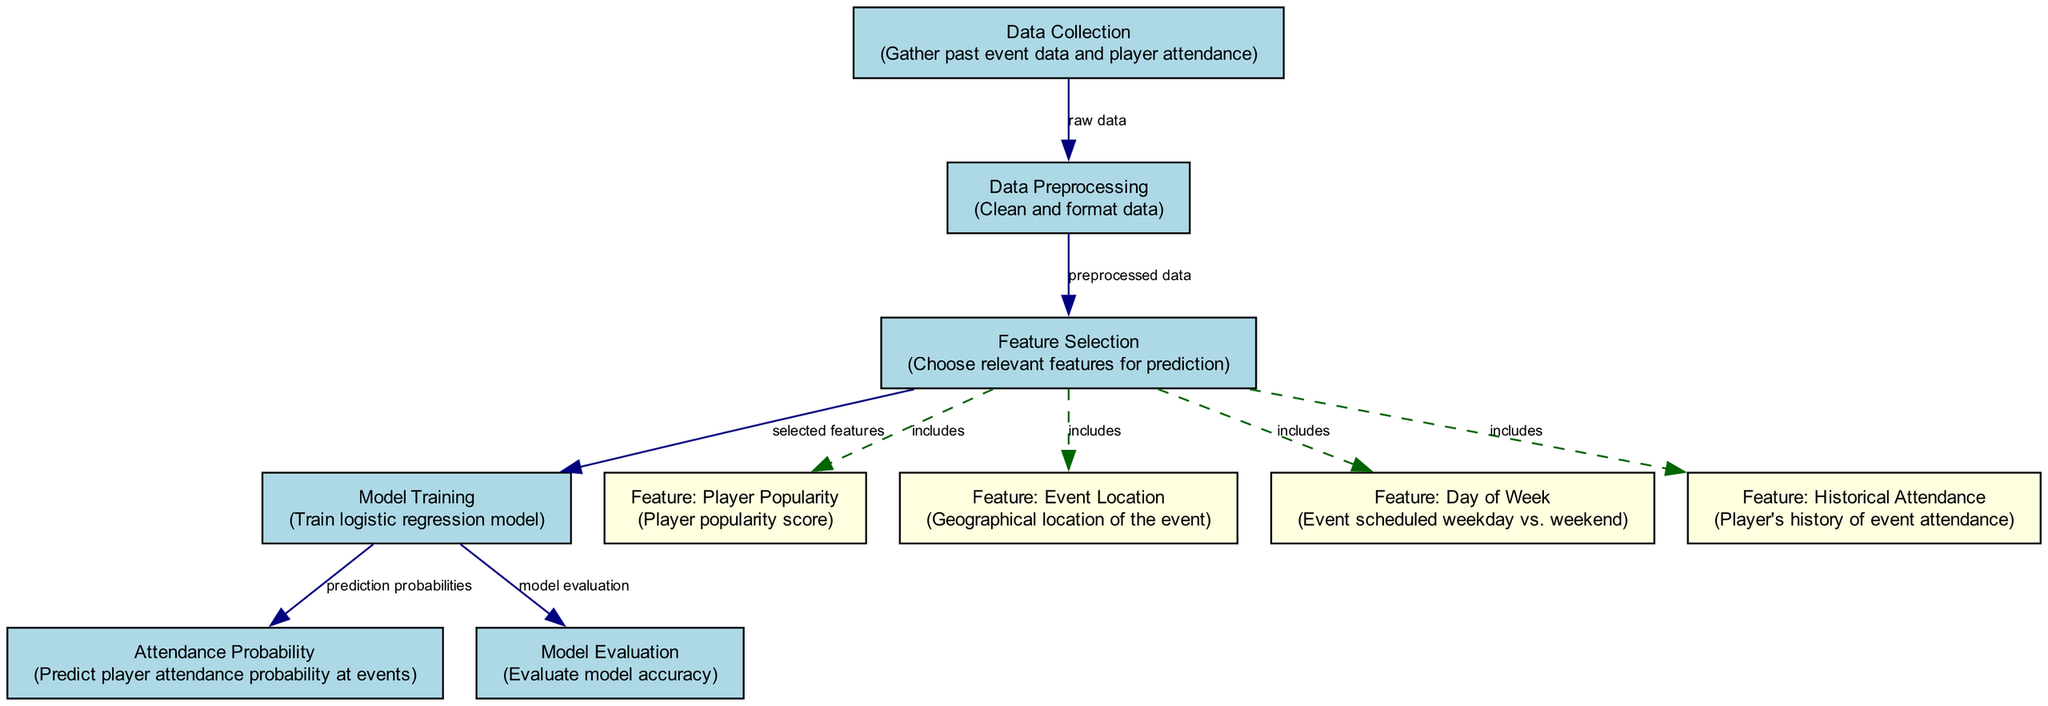What is the first step in the diagram? The first step, indicated by the node "Data Collection," involves gathering past event data and player attendance. This is how the process initiates before any further analysis.
Answer: Data Collection How many nodes are there in total? The diagram has a total of ten nodes, each representing different stages or components of the personalized autograph prediction model.
Answer: Ten What type of model is being trained? The diagram indicates that a logistic regression model is being trained in the "Model Training" node, which focuses on predicting outcomes based on certain features.
Answer: Logistic Regression Which feature is related to the geographical aspect of the events? The "Event Location" feature is specifically related to the geographical aspect of the events, indicating where the events are held and how that may influence player attendance.
Answer: Event Location What does the edge from "Model Training" to "Model Evaluation" represent? This edge represents the transition from training the model to evaluating its accuracy, indicating that after a model is trained, it must undergo an assessment to determine its effectiveness.
Answer: Model evaluation How many features are included in the feature selection process? The feature selection process includes four features: Player Popularity, Event Location, Day of Week, and Historical Attendance. This selection is crucial for making informed predictions on player attendance.
Answer: Four What is the output of the "Model Training" node? The output from the "Model Training" node is defined as "prediction probabilities," indicating the likelihood of player attendance at upcoming events.
Answer: Prediction probabilities What is the relationship between "Feature Selection" and "Model Training"? The relationship is that "Feature Selection" provides the selected features that feed into "Model Training," ensuring that only relevant data informs the training process of the logistic regression model.
Answer: Selected features Which feature assesses a player’s engagement level at past events? The "Historical Attendance" feature assesses a player’s engagement level at past events, reflecting how often a player has attended similar events in the past, which can inform predictions for future attendance.
Answer: Historical Attendance 